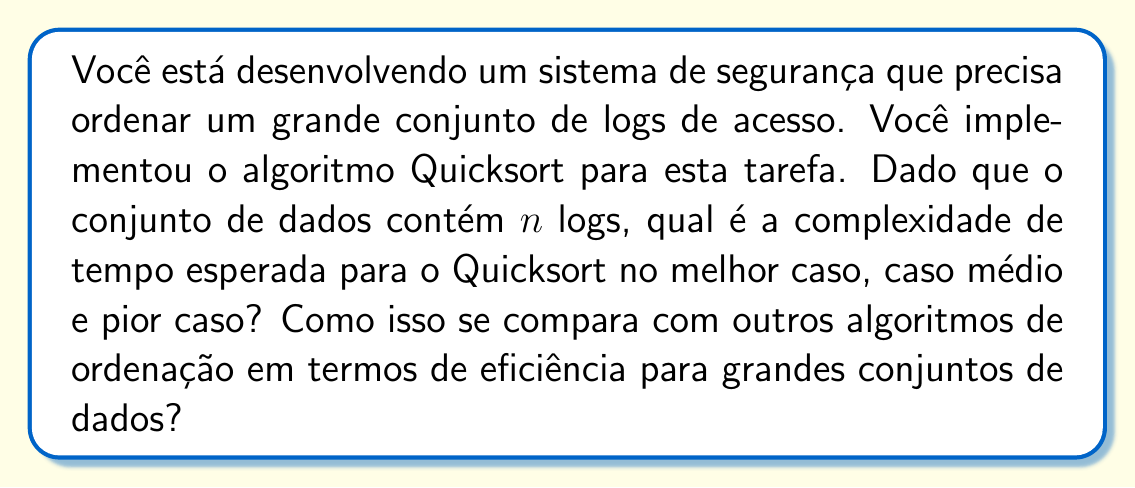Can you answer this question? Para analisar a eficiência do Quicksort, vamos considerar suas complexidades de tempo em diferentes cenários:

1. Melhor caso:
   O melhor caso ocorre quando o pivô escolhido sempre divide o array em duas partes iguais. Neste caso, a recorrência é:

   $$T(n) = 2T(n/2) + O(n)$$

   Resolvendo esta recorrência, obtemos:
   $$T(n) = O(n \log n)$$

2. Caso médio:
   No caso médio, o pivô não divide o array exatamente ao meio, mas ainda fornece uma divisão razoavelmente equilibrada. A análise probabilística mostra que o caso médio também resulta em:

   $$T(n) = O(n \log n)$$

3. Pior caso:
   O pior caso ocorre quando o pivô escolhido é sempre o elemento mínimo ou máximo, resultando em uma divisão muito desequilibrada. A recorrência neste caso é:

   $$T(n) = T(n-1) + O(n)$$

   Resolvendo esta recorrência, obtemos:
   $$T(n) = O(n^2)$$

Comparação com outros algoritmos:

1. Mergesort: $O(n \log n)$ em todos os casos
2. Heapsort: $O(n \log n)$ em todos os casos
3. Insertion Sort: $O(n^2)$ no pior e caso médio, $O(n)$ no melhor caso
4. Bubble Sort: $O(n^2)$ em todos os casos

Para grandes conjuntos de dados, o Quicksort é geralmente mais eficiente na prática devido a:

1. Bom desempenho no caso médio $(O(n \log n))$
2. Boa localidade de cache
3. Baixo overhead constante

No entanto, para garantir segurança e confiabilidade, é importante implementar técnicas para evitar o pior caso, como:

1. Escolha aleatória do pivô
2. Mediana de três para seleção do pivô
3. Introsort (combinação de Quicksort e Heapsort)

Estas técnicas ajudam a manter a eficiência do Quicksort para grandes conjuntos de dados, tornando-o uma escolha adequada para ordenar logs de acesso em um sistema de segurança.
Answer: Melhor caso e caso médio: $O(n \log n)$
Pior caso: $O(n^2)$
Quicksort é geralmente eficiente para grandes conjuntos de dados devido ao bom desempenho médio, boa localidade de cache e baixo overhead constante, mas requer técnicas para evitar o pior caso. 